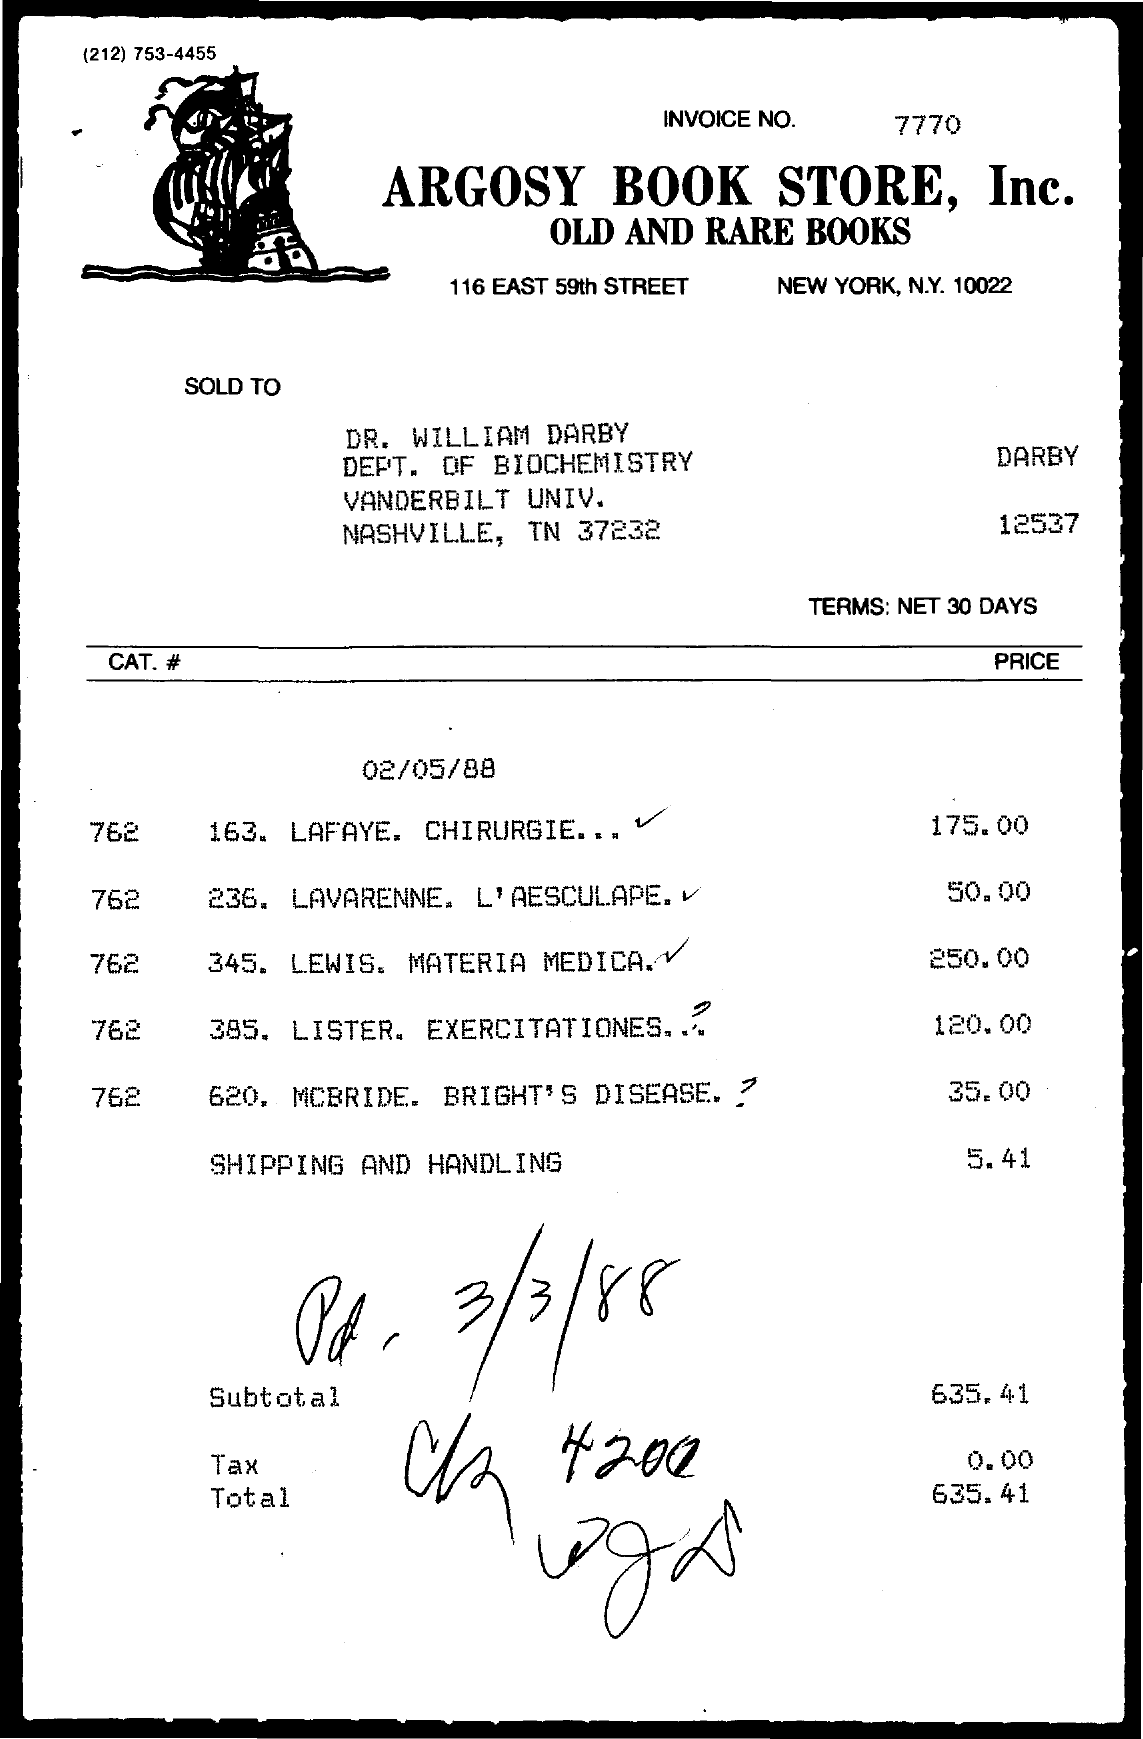What is the Invoice No.?
Your response must be concise. 7770. 